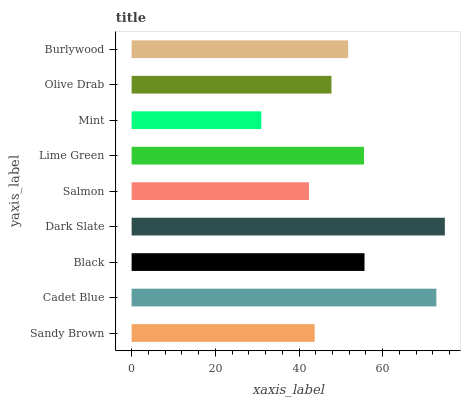Is Mint the minimum?
Answer yes or no. Yes. Is Dark Slate the maximum?
Answer yes or no. Yes. Is Cadet Blue the minimum?
Answer yes or no. No. Is Cadet Blue the maximum?
Answer yes or no. No. Is Cadet Blue greater than Sandy Brown?
Answer yes or no. Yes. Is Sandy Brown less than Cadet Blue?
Answer yes or no. Yes. Is Sandy Brown greater than Cadet Blue?
Answer yes or no. No. Is Cadet Blue less than Sandy Brown?
Answer yes or no. No. Is Burlywood the high median?
Answer yes or no. Yes. Is Burlywood the low median?
Answer yes or no. Yes. Is Dark Slate the high median?
Answer yes or no. No. Is Salmon the low median?
Answer yes or no. No. 